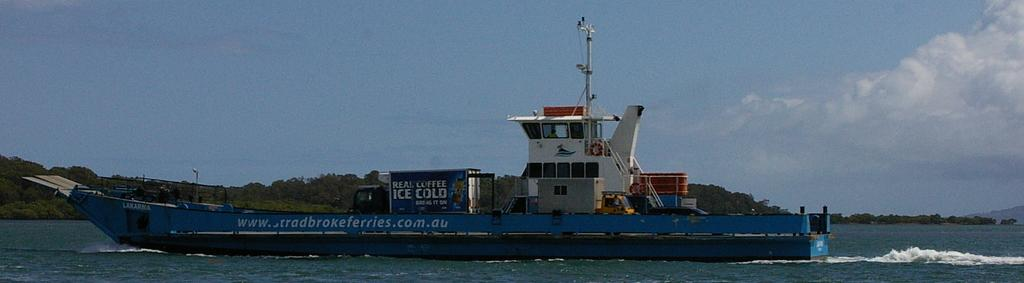What is the main subject of the image? The main subject of the image is a ship. Where is the ship located in the image? The ship is on the water. What other geographical feature can be seen in the image? There is a hill in the middle of the image. What is visible at the top of the image? The sky is visible at the top of the image. What type of cough does the ship have in the image? The ship does not have a cough in the image, as it is an inanimate object and cannot experience a cough. 